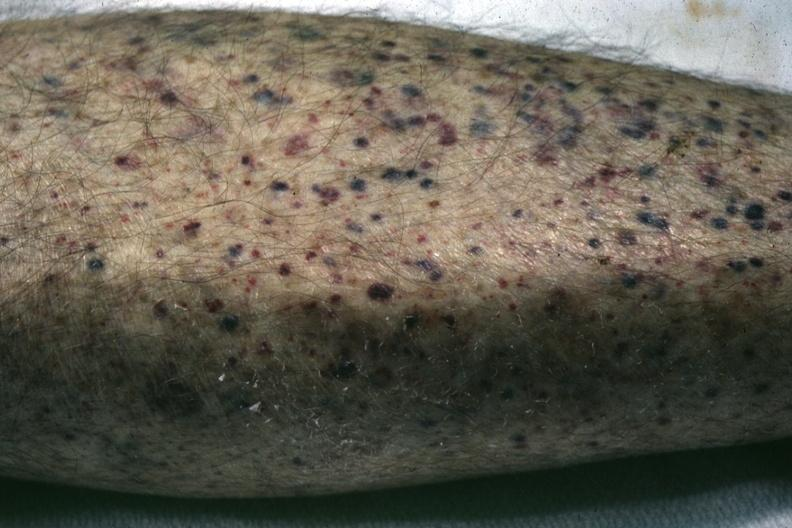does gross show white skin close-up view quite good?
Answer the question using a single word or phrase. No 